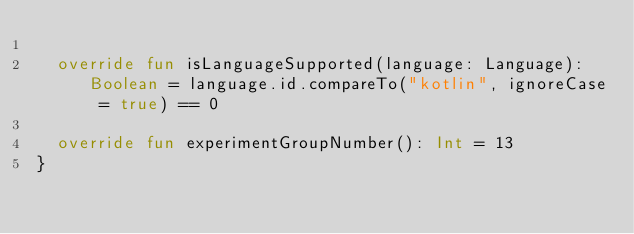Convert code to text. <code><loc_0><loc_0><loc_500><loc_500><_Kotlin_>
  override fun isLanguageSupported(language: Language): Boolean = language.id.compareTo("kotlin", ignoreCase = true) == 0

  override fun experimentGroupNumber(): Int = 13
}</code> 